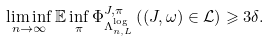<formula> <loc_0><loc_0><loc_500><loc_500>\liminf _ { n \rightarrow \infty } \mathbb { E } \inf _ { \pi } \Phi _ { \Lambda _ { n , L } ^ { \log } } ^ { J , \pi } \left ( ( J , \omega ) \in \mathcal { L } \right ) \geqslant 3 \delta .</formula> 